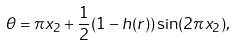Convert formula to latex. <formula><loc_0><loc_0><loc_500><loc_500>\theta = \pi x _ { 2 } + \frac { 1 } { 2 } ( 1 - h ( r ) ) \sin ( 2 \pi x _ { 2 } ) ,</formula> 